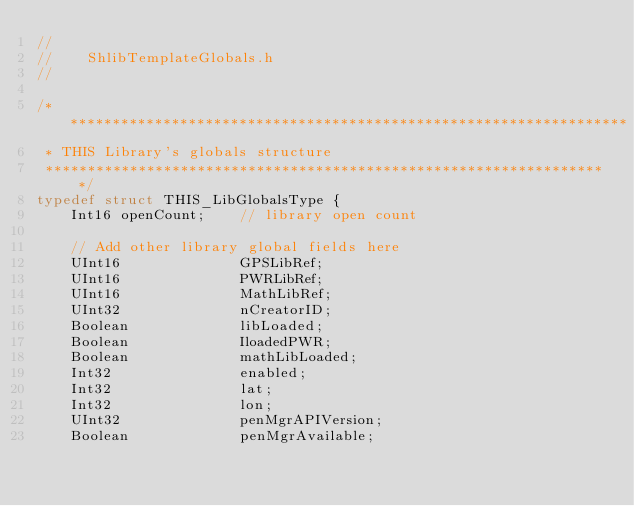Convert code to text. <code><loc_0><loc_0><loc_500><loc_500><_C_>//
//    ShlibTemplateGlobals.h
//

/*******************************************************************
 * THIS Library's globals structure
 *******************************************************************/
typedef struct THIS_LibGlobalsType {
    Int16 openCount;    // library open count
	
    // Add other library global fields here
	UInt16              GPSLibRef;
	UInt16              PWRLibRef;
	UInt16              MathLibRef;
	UInt32              nCreatorID;
	Boolean             libLoaded;
	Boolean             IloadedPWR;
	Boolean             mathLibLoaded;
	Int32               enabled;
	Int32               lat;
	Int32               lon;
	UInt32              penMgrAPIVersion;
	Boolean             penMgrAvailable;</code> 